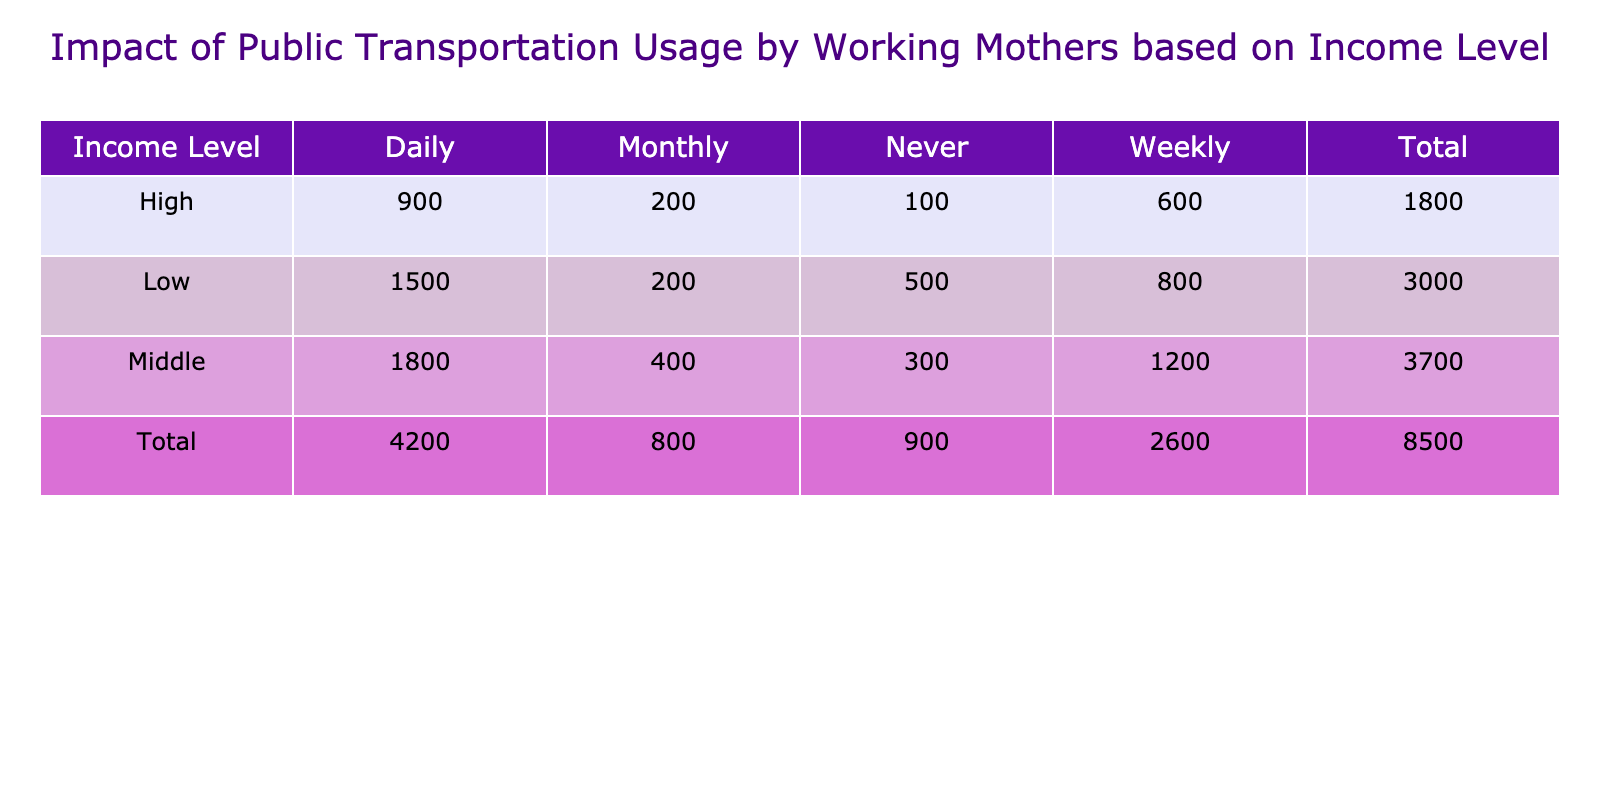What is the total number of working mothers in the low-income group? From the table, the total number of working mothers in the low-income group can be calculated by adding the counts for each public transportation usage frequency: 1500 (daily) + 800 (weekly) + 200 (monthly) + 500 (never) = 3000.
Answer: 3000 How many working mothers in the middle-income group use public transportation daily? According to the table, there are 1800 working mothers in the middle-income group who use public transportation daily.
Answer: 1800 Is the number of high-income working mothers who use public transportation weekly greater than those who use it monthly? The table shows 600 high-income working mothers using public transportation weekly and 200 using it monthly. Since 600 is greater than 200, the statement is true.
Answer: Yes What is the average number of working mothers who use public transportation daily across all income levels? To calculate the average, sum the counts of daily users for each income level: 1500 (low) + 1800 (middle) + 900 (high) = 4200. Then, divide by the number of income levels (3): 4200 / 3 = 1400.
Answer: 1400 What is the total number of working mothers who never use public transportation? The total number of working mothers who never use public transportation can be found by adding the counts: 500 (low) + 300 (middle) + 100 (high) = 900.
Answer: 900 Does the middle-income group have more working mothers using public transportation weekly or daily? According to the table, the middle-income group has 1200 who use it weekly and 1800 who use it daily. Since 1800 is greater than 1200, the middle-income group has more daily users.
Answer: Daily What percentage of working mothers in the low-income group never use public transportation? The total number of working mothers in the low-income group is 3000, with 500 never using public transportation. The percentage is calculated as (500 / 3000) * 100 = 16.67%.
Answer: 16.67% Which income level has the least number of working mothers using public transportation monthly? By checking the counts for monthly usage: 200 (low), 400 (middle), and 200 (high), both low and high income have the least at 200.
Answer: Low and High What is the difference in the number of working mothers using public transportation daily between low and high income levels? From the table, there are 1500 daily users in the low-income group and 900 in the high-income group. The difference is 1500 - 900 = 600.
Answer: 600 